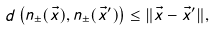Convert formula to latex. <formula><loc_0><loc_0><loc_500><loc_500>d \left ( n _ { \pm } ( \vec { x } ) , n _ { \pm } ( \vec { x } ^ { \prime } ) \right ) \leq \| \vec { x } - \vec { x } ^ { \prime } \| ,</formula> 